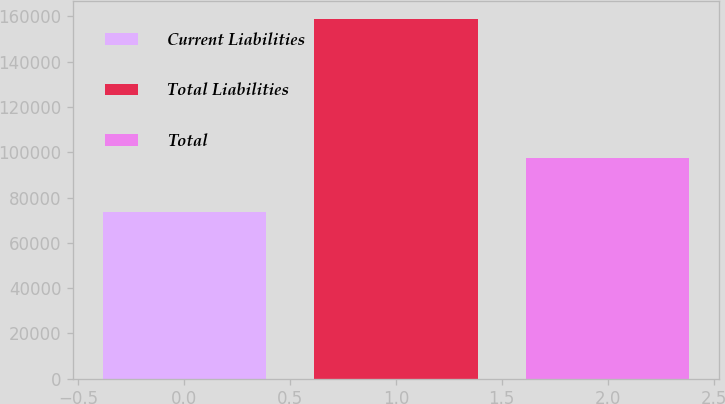Convert chart. <chart><loc_0><loc_0><loc_500><loc_500><bar_chart><fcel>Current Liabilities<fcel>Total Liabilities<fcel>Total<nl><fcel>73741<fcel>159005<fcel>97415<nl></chart> 